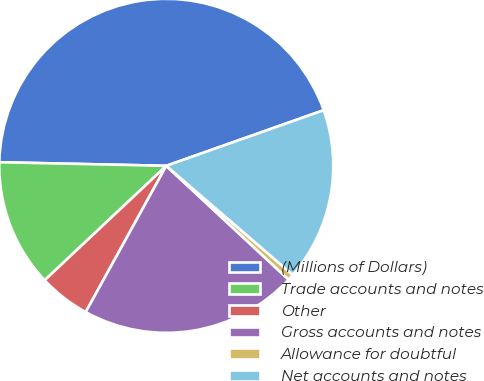<chart> <loc_0><loc_0><loc_500><loc_500><pie_chart><fcel>(Millions of Dollars)<fcel>Trade accounts and notes<fcel>Other<fcel>Gross accounts and notes<fcel>Allowance for doubtful<fcel>Net accounts and notes<nl><fcel>44.25%<fcel>12.36%<fcel>4.97%<fcel>21.09%<fcel>0.6%<fcel>16.73%<nl></chart> 